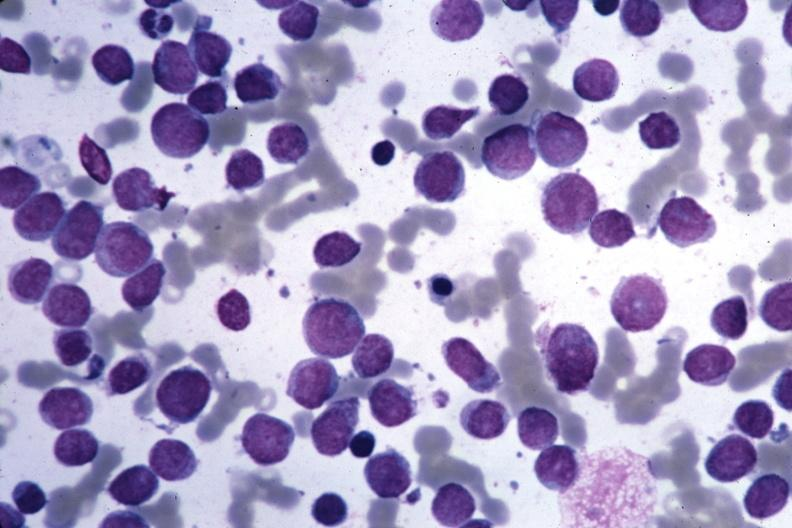s hematologic present?
Answer the question using a single word or phrase. Yes 